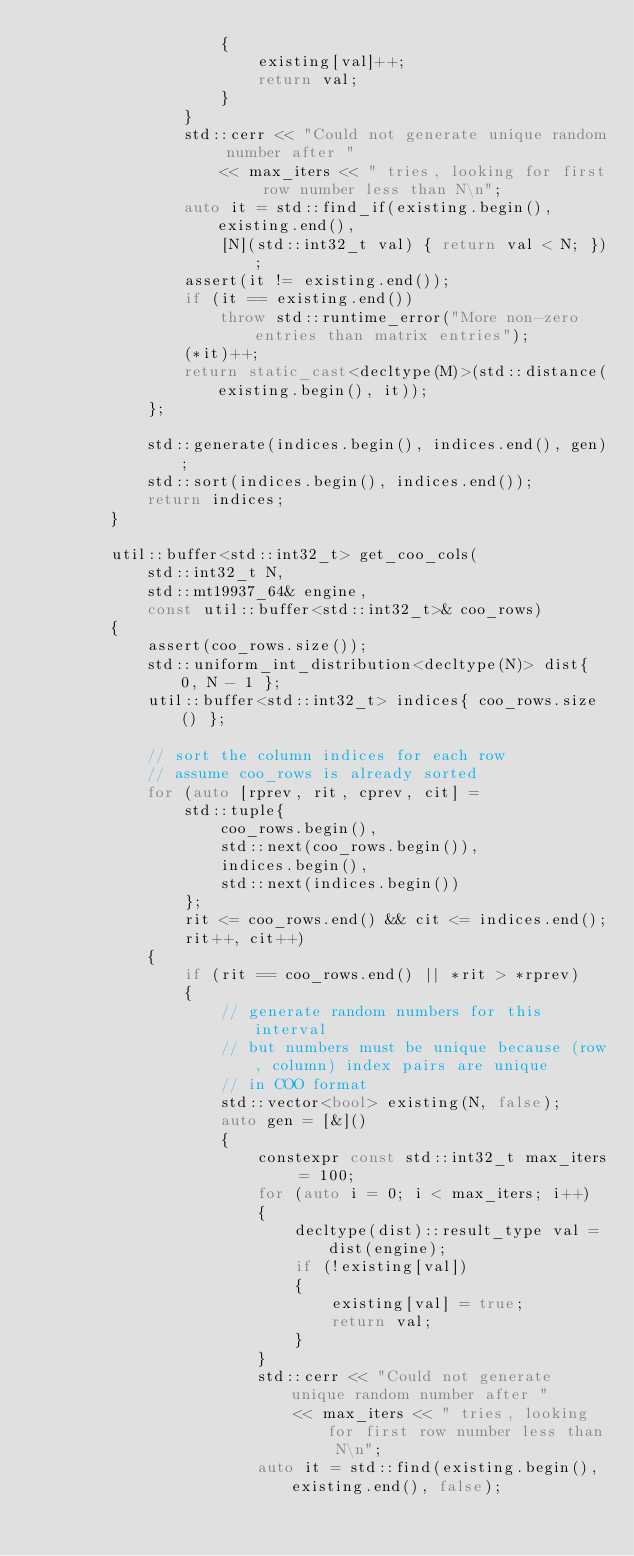<code> <loc_0><loc_0><loc_500><loc_500><_C++_>                    {
                        existing[val]++;
                        return val;
                    }
                }
                std::cerr << "Could not generate unique random number after "
                    << max_iters << " tries, looking for first row number less than N\n";
                auto it = std::find_if(existing.begin(), existing.end(),
                    [N](std::int32_t val) { return val < N; });
                assert(it != existing.end());
                if (it == existing.end())
                    throw std::runtime_error("More non-zero entries than matrix entries");
                (*it)++;
                return static_cast<decltype(M)>(std::distance(existing.begin(), it));
            };

            std::generate(indices.begin(), indices.end(), gen);
            std::sort(indices.begin(), indices.end());
            return indices;
        }

        util::buffer<std::int32_t> get_coo_cols(
            std::int32_t N,
            std::mt19937_64& engine,
            const util::buffer<std::int32_t>& coo_rows)
        {
            assert(coo_rows.size());
            std::uniform_int_distribution<decltype(N)> dist{ 0, N - 1 };
            util::buffer<std::int32_t> indices{ coo_rows.size() };

            // sort the column indices for each row
            // assume coo_rows is already sorted
            for (auto [rprev, rit, cprev, cit] =
                std::tuple{
                    coo_rows.begin(),
                    std::next(coo_rows.begin()),
                    indices.begin(),
                    std::next(indices.begin())
                };
                rit <= coo_rows.end() && cit <= indices.end();
                rit++, cit++)
            {
                if (rit == coo_rows.end() || *rit > *rprev)
                {
                    // generate random numbers for this interval
                    // but numbers must be unique because (row, column) index pairs are unique
                    // in COO format
                    std::vector<bool> existing(N, false);
                    auto gen = [&]()
                    {
                        constexpr const std::int32_t max_iters = 100;
                        for (auto i = 0; i < max_iters; i++)
                        {
                            decltype(dist)::result_type val = dist(engine);
                            if (!existing[val])
                            {
                                existing[val] = true;
                                return val;
                            }
                        }
                        std::cerr << "Could not generate unique random number after "
                            << max_iters << " tries, looking for first row number less than N\n";
                        auto it = std::find(existing.begin(), existing.end(), false);</code> 